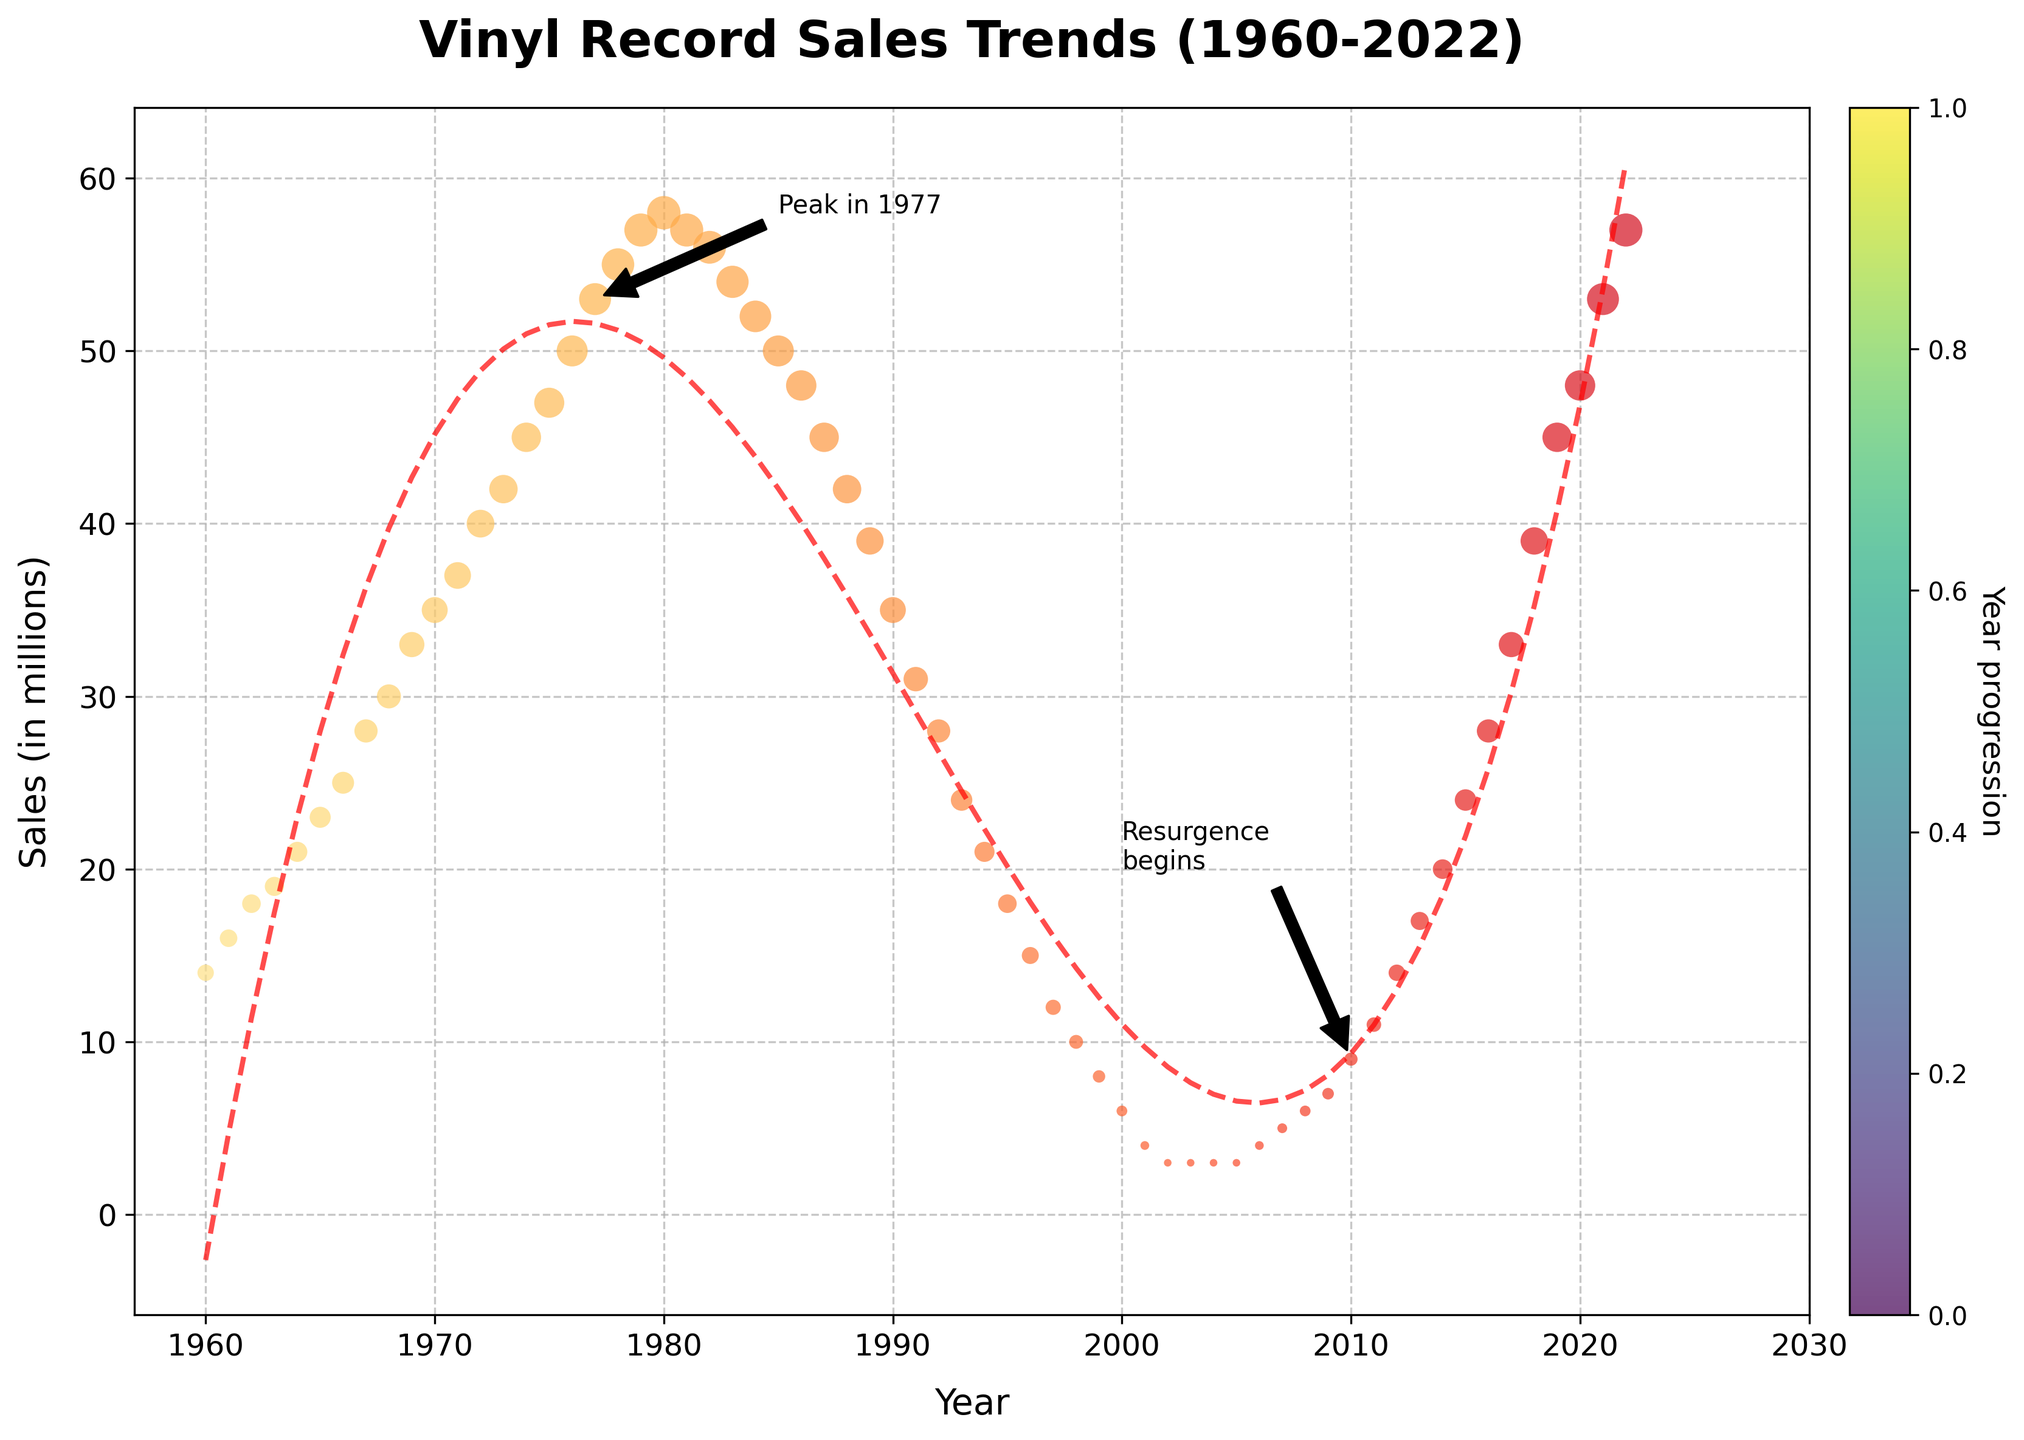What is the title of the figure? The title of the figure is located at the top and describes the main topic of the plot. It tells us what the figure shows.
Answer: Vinyl Record Sales Trends (1960-2022) In which year did vinyl record sales peak according to the figure? The peak in vinyl record sales is marked by both a label and an annotation arrow pointing to the highest data point.
Answer: 1977 How would you describe the trend of vinyl record sales from 1980 to 2000? By observing the scatter plot and the trend line, we can see that the sales are continuously declining during this period.
Answer: Declining When did the resurgence in vinyl record sales begin, according to the annotations in the figure? The annotation labeled "Resurgence begins" points to a specific year when the upward trend in sales started after a period of decline.
Answer: 2010 How many sales (in millions) were there in 2022? By looking at the 2022 data point on the y-axis, we can find the corresponding sales value.
Answer: 57 million Between which two decades did vinyl record sales experience the greatest decline? To determine the greatest decline, we need to compare the differences in sales between consecutive decades and identify which two decades have the largest change.
Answer: 1980-1990 What color scheme is used for the data points in the plot? The colors of the data points follow a gradient from yellow to red, consistent with the `YlOrRd` color scheme.
Answer: Yellow to Red gradient Which year had the lowest vinyl record sales according to the figure? By identifying the data point with the minimum y-value, we can see which year had the lowest sales.
Answer: 2002 Compare the sales in 1977 and 2010. Which year had higher sales and by how much? Refer to the sales values for both years on the y-axis and calculate the difference. Sales in 1977 were 53 million, and in 2010 were 9 million. The difference is 53 - 9.
Answer: 1977 by 44 million What is the purpose of the trend line in the plot? The trend line helps to visualize the overall pattern or trend of the data over the given period, smoothing out short-term fluctuations to show the long-term direction.
Answer: Visualize the trend of the data 